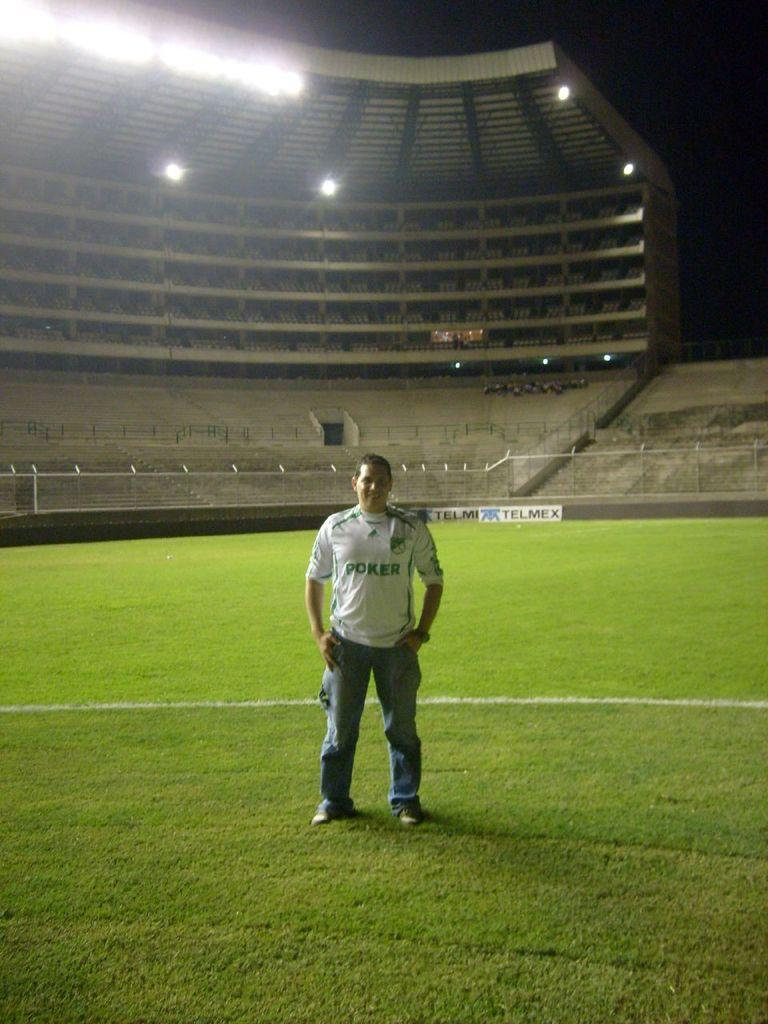Provide a one-sentence caption for the provided image. A man standing on the field with a shirt that says poker. 